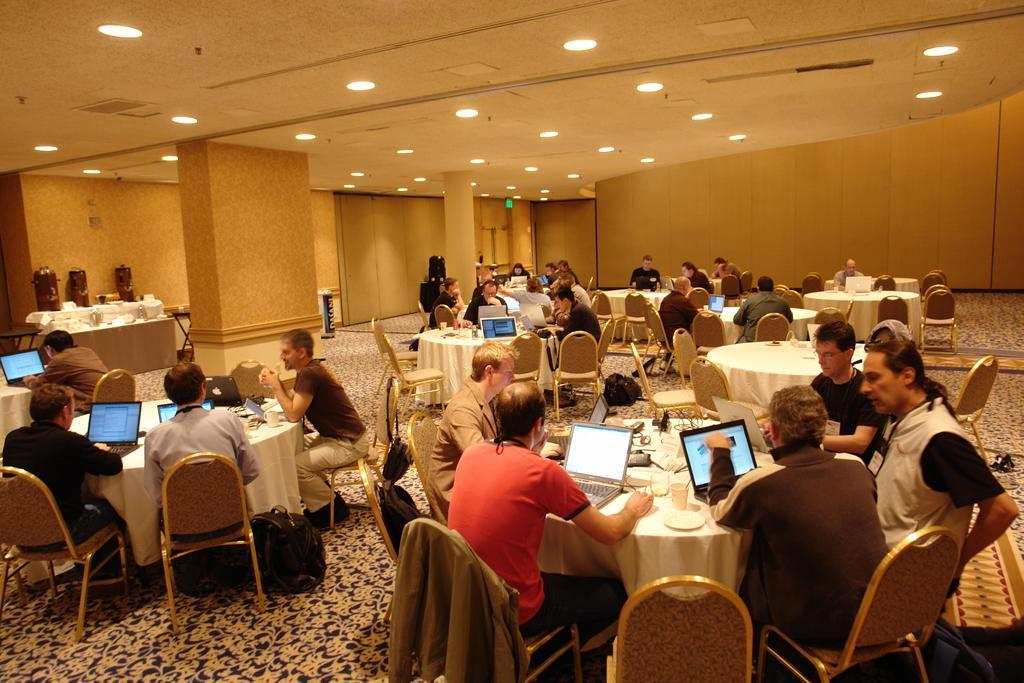Can you describe this image briefly? There are many people sitting in the chairs around a table on which some laptops, glasses and some food items were placed in the background, there is a wall, pillar here. 